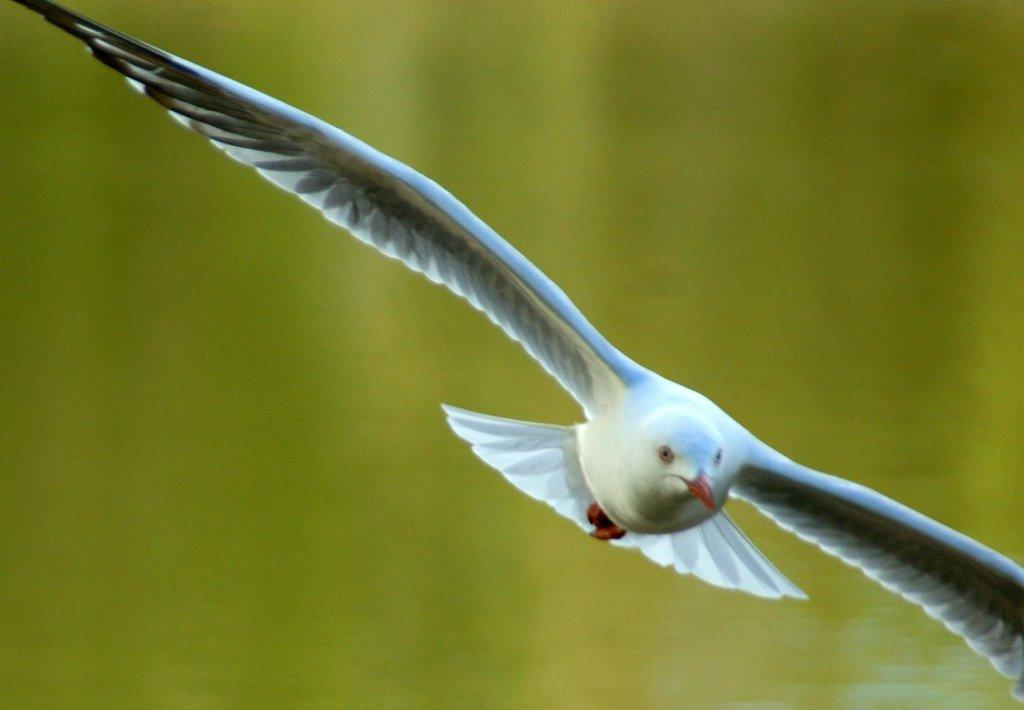What animal can be seen in the picture? There is a bird in the picture. Can you describe the bird's appearance? The bird has white and black feathers. What is the bird doing in the picture? The bird is flying. What color is the background of the picture? The background of the picture has a green color. What type of feeling does the bird have while sitting on the branch in the picture? There is no branch present in the picture, and the bird is flying, not sitting. Additionally, feelings cannot be determined from a visual image. 